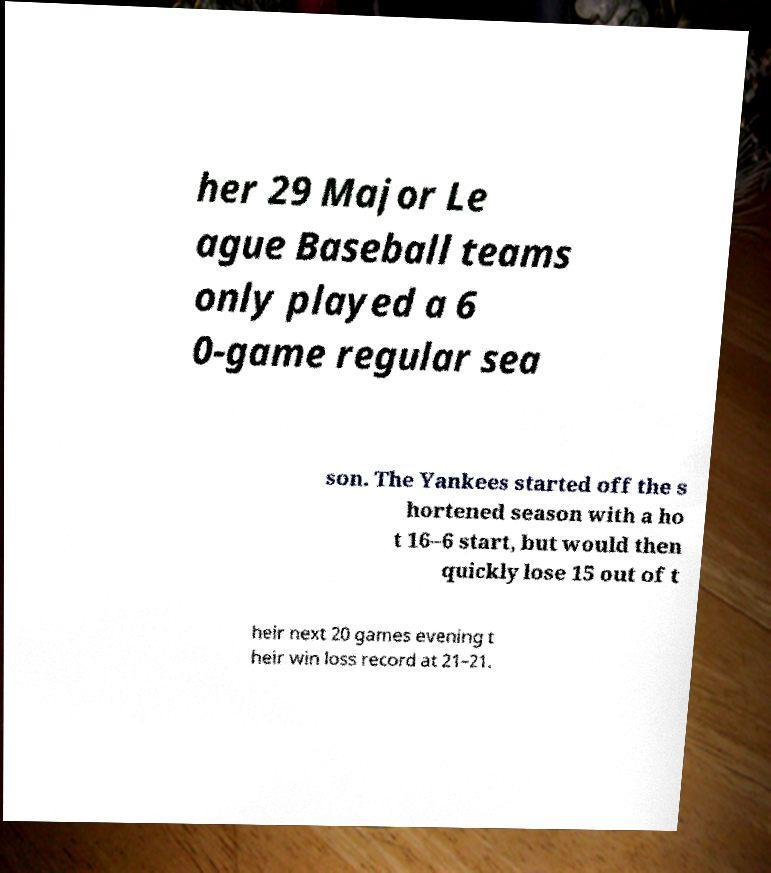Please read and relay the text visible in this image. What does it say? her 29 Major Le ague Baseball teams only played a 6 0-game regular sea son. The Yankees started off the s hortened season with a ho t 16–6 start, but would then quickly lose 15 out of t heir next 20 games evening t heir win loss record at 21–21. 